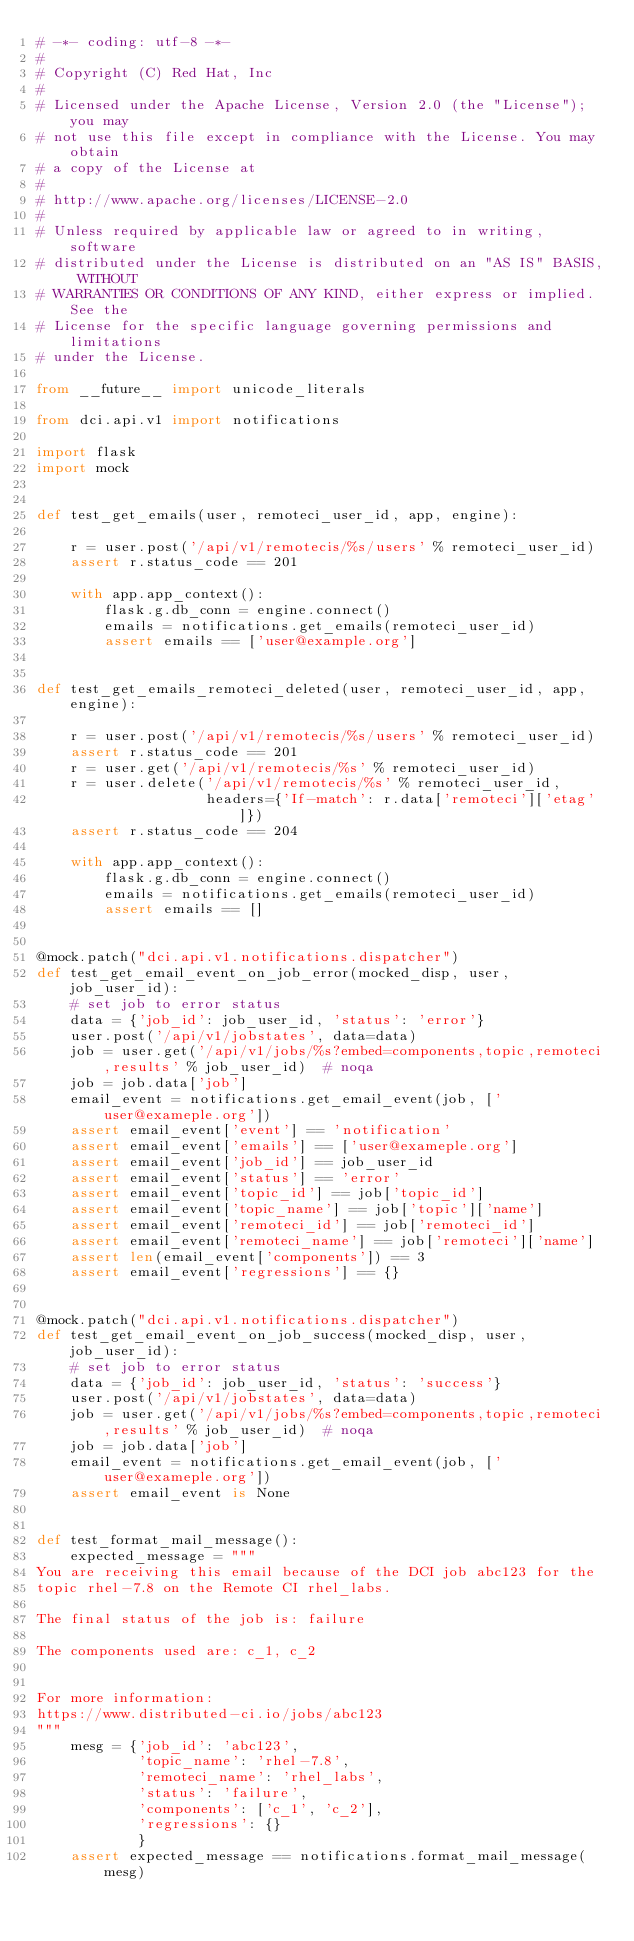Convert code to text. <code><loc_0><loc_0><loc_500><loc_500><_Python_># -*- coding: utf-8 -*-
#
# Copyright (C) Red Hat, Inc
#
# Licensed under the Apache License, Version 2.0 (the "License"); you may
# not use this file except in compliance with the License. You may obtain
# a copy of the License at
#
# http://www.apache.org/licenses/LICENSE-2.0
#
# Unless required by applicable law or agreed to in writing, software
# distributed under the License is distributed on an "AS IS" BASIS, WITHOUT
# WARRANTIES OR CONDITIONS OF ANY KIND, either express or implied. See the
# License for the specific language governing permissions and limitations
# under the License.

from __future__ import unicode_literals

from dci.api.v1 import notifications

import flask
import mock


def test_get_emails(user, remoteci_user_id, app, engine):

    r = user.post('/api/v1/remotecis/%s/users' % remoteci_user_id)
    assert r.status_code == 201

    with app.app_context():
        flask.g.db_conn = engine.connect()
        emails = notifications.get_emails(remoteci_user_id)
        assert emails == ['user@example.org']


def test_get_emails_remoteci_deleted(user, remoteci_user_id, app, engine):

    r = user.post('/api/v1/remotecis/%s/users' % remoteci_user_id)
    assert r.status_code == 201
    r = user.get('/api/v1/remotecis/%s' % remoteci_user_id)
    r = user.delete('/api/v1/remotecis/%s' % remoteci_user_id,
                    headers={'If-match': r.data['remoteci']['etag']})
    assert r.status_code == 204

    with app.app_context():
        flask.g.db_conn = engine.connect()
        emails = notifications.get_emails(remoteci_user_id)
        assert emails == []


@mock.patch("dci.api.v1.notifications.dispatcher")
def test_get_email_event_on_job_error(mocked_disp, user, job_user_id):
    # set job to error status
    data = {'job_id': job_user_id, 'status': 'error'}
    user.post('/api/v1/jobstates', data=data)
    job = user.get('/api/v1/jobs/%s?embed=components,topic,remoteci,results' % job_user_id)  # noqa
    job = job.data['job']
    email_event = notifications.get_email_event(job, ['user@exameple.org'])
    assert email_event['event'] == 'notification'
    assert email_event['emails'] == ['user@exameple.org']
    assert email_event['job_id'] == job_user_id
    assert email_event['status'] == 'error'
    assert email_event['topic_id'] == job['topic_id']
    assert email_event['topic_name'] == job['topic']['name']
    assert email_event['remoteci_id'] == job['remoteci_id']
    assert email_event['remoteci_name'] == job['remoteci']['name']
    assert len(email_event['components']) == 3
    assert email_event['regressions'] == {}


@mock.patch("dci.api.v1.notifications.dispatcher")
def test_get_email_event_on_job_success(mocked_disp, user, job_user_id):
    # set job to error status
    data = {'job_id': job_user_id, 'status': 'success'}
    user.post('/api/v1/jobstates', data=data)
    job = user.get('/api/v1/jobs/%s?embed=components,topic,remoteci,results' % job_user_id)  # noqa
    job = job.data['job']
    email_event = notifications.get_email_event(job, ['user@exameple.org'])
    assert email_event is None


def test_format_mail_message():
    expected_message = """
You are receiving this email because of the DCI job abc123 for the
topic rhel-7.8 on the Remote CI rhel_labs.

The final status of the job is: failure

The components used are: c_1, c_2


For more information:
https://www.distributed-ci.io/jobs/abc123
"""
    mesg = {'job_id': 'abc123',
            'topic_name': 'rhel-7.8',
            'remoteci_name': 'rhel_labs',
            'status': 'failure',
            'components': ['c_1', 'c_2'],
            'regressions': {}
            }
    assert expected_message == notifications.format_mail_message(mesg)
</code> 